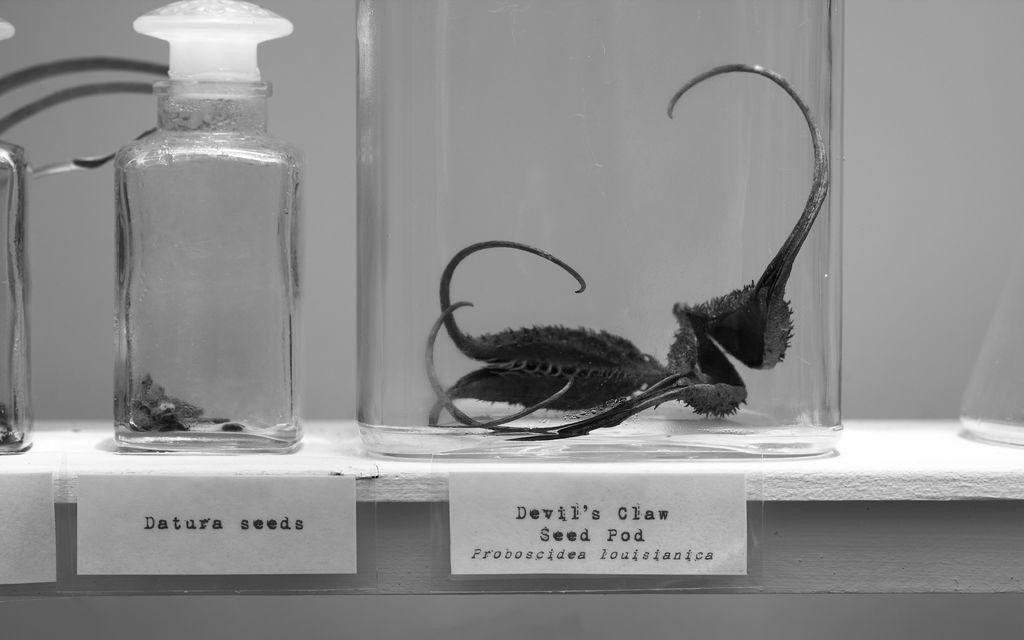What is contained in the glass jar in the image? There is a display of species in a glass jar in the image. Is there any information provided about the contents of the jar? Yes, there is a name plate in the image. What can be seen in the background of the image? There is a wall in the background of the image. How many houses are visible in the image? There are no houses visible in the image. Which leg of the species in the jar is longer? There is no leg present in the image, as it features a display of species in a glass jar. 